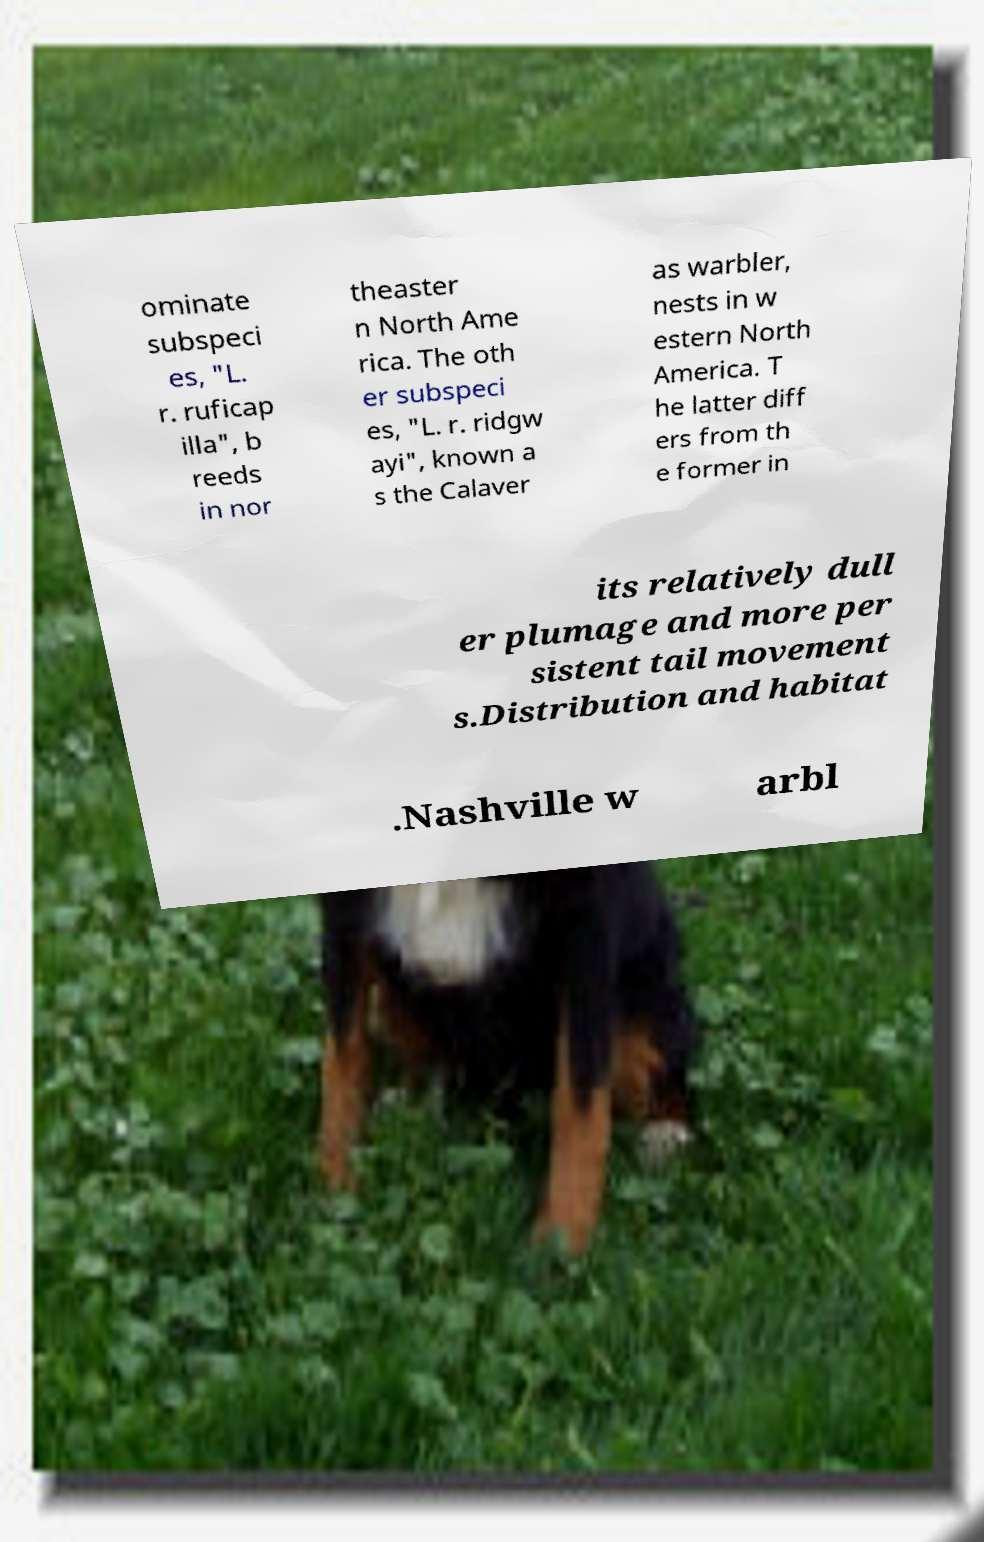Please identify and transcribe the text found in this image. ominate subspeci es, "L. r. ruficap illa", b reeds in nor theaster n North Ame rica. The oth er subspeci es, "L. r. ridgw ayi", known a s the Calaver as warbler, nests in w estern North America. T he latter diff ers from th e former in its relatively dull er plumage and more per sistent tail movement s.Distribution and habitat .Nashville w arbl 